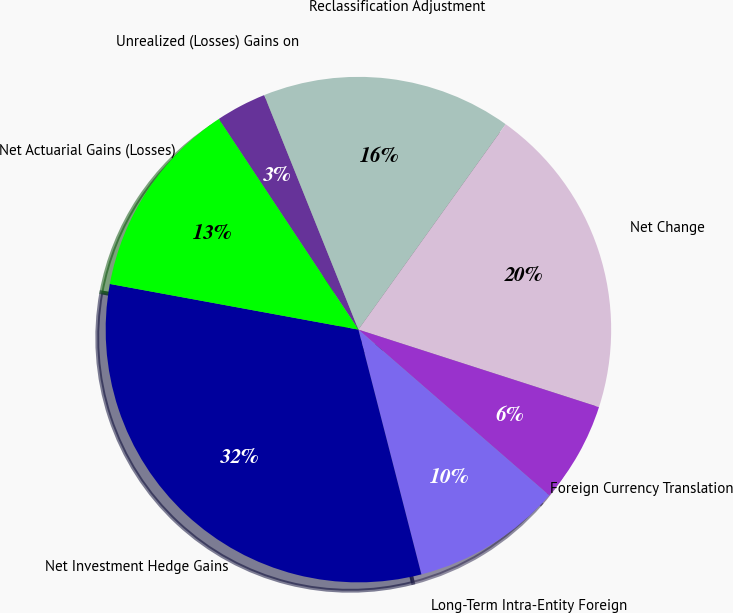Convert chart to OTSL. <chart><loc_0><loc_0><loc_500><loc_500><pie_chart><fcel>Unrealized (Losses) Gains on<fcel>Reclassification Adjustment<fcel>Net Change<fcel>Foreign Currency Translation<fcel>Long-Term Intra-Entity Foreign<fcel>Net Investment Hedge Gains<fcel>Net Actuarial Gains (Losses)<nl><fcel>3.24%<fcel>15.98%<fcel>20.06%<fcel>6.42%<fcel>9.61%<fcel>31.9%<fcel>12.79%<nl></chart> 